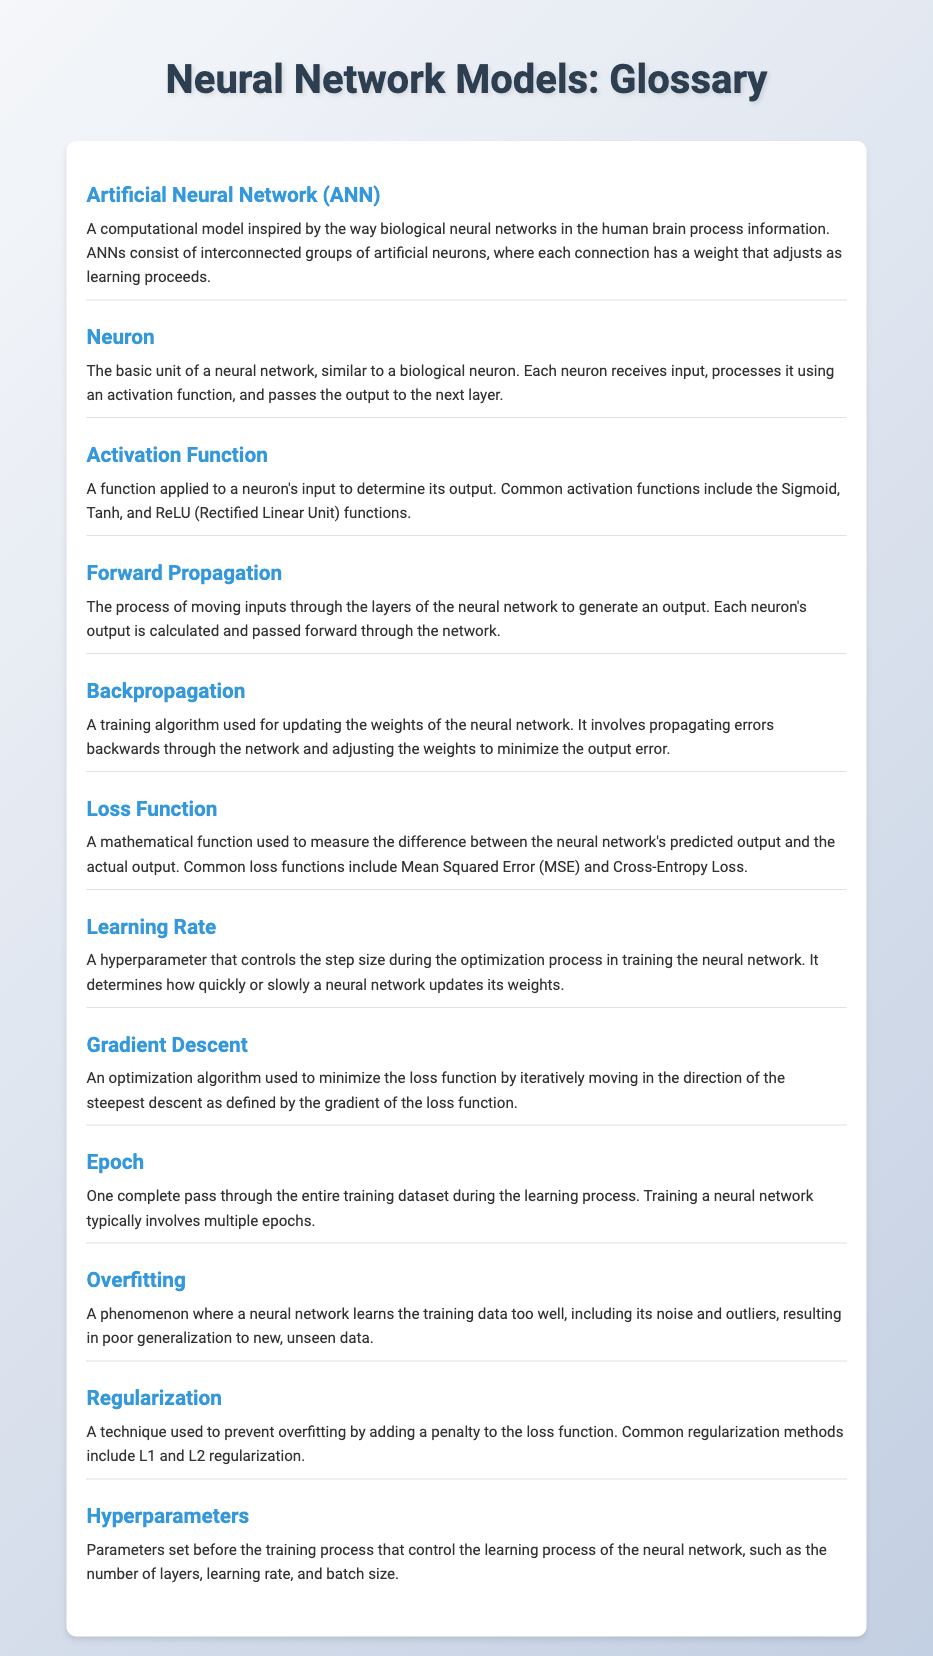What is the title of the document? The title of the document is provided in the <title> tag of the HTML, which is "Neural Network Glossary".
Answer: Neural Network Glossary What does ANN stand for? The acronym ANN appears in the definition of Artificial Neural Network.
Answer: Artificial Neural Network Which function determines a neuron's output? The explanation for Neuron mentions that an activation function determines a neuron's output.
Answer: Activation Function What is the purpose of Backpropagation? The definition of Backpropagation describes its purpose as updating the weights of the neural network.
Answer: Updating the weights What is the common loss function mentioned in the document? The Loss Function section mentions Mean Squared Error (MSE) and Cross-Entropy Loss as common examples.
Answer: Mean Squared Error What is the role of the Learning Rate in neural network training? The definition of Learning Rate specifies it controls the step size during the optimization process.
Answer: Step size How many epochs typically involve training a neural network? The Epoch term states that training a neural network typically involves multiple epochs.
Answer: Multiple Which phenomenon occurs when a neural network learns the training data too well? The document refers to this as Overfitting in the respective section.
Answer: Overfitting What technique is used to prevent overfitting? The Regularization section mentions adding a penalty to the loss function as a common technique.
Answer: Regularization 